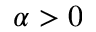<formula> <loc_0><loc_0><loc_500><loc_500>\alpha > 0</formula> 